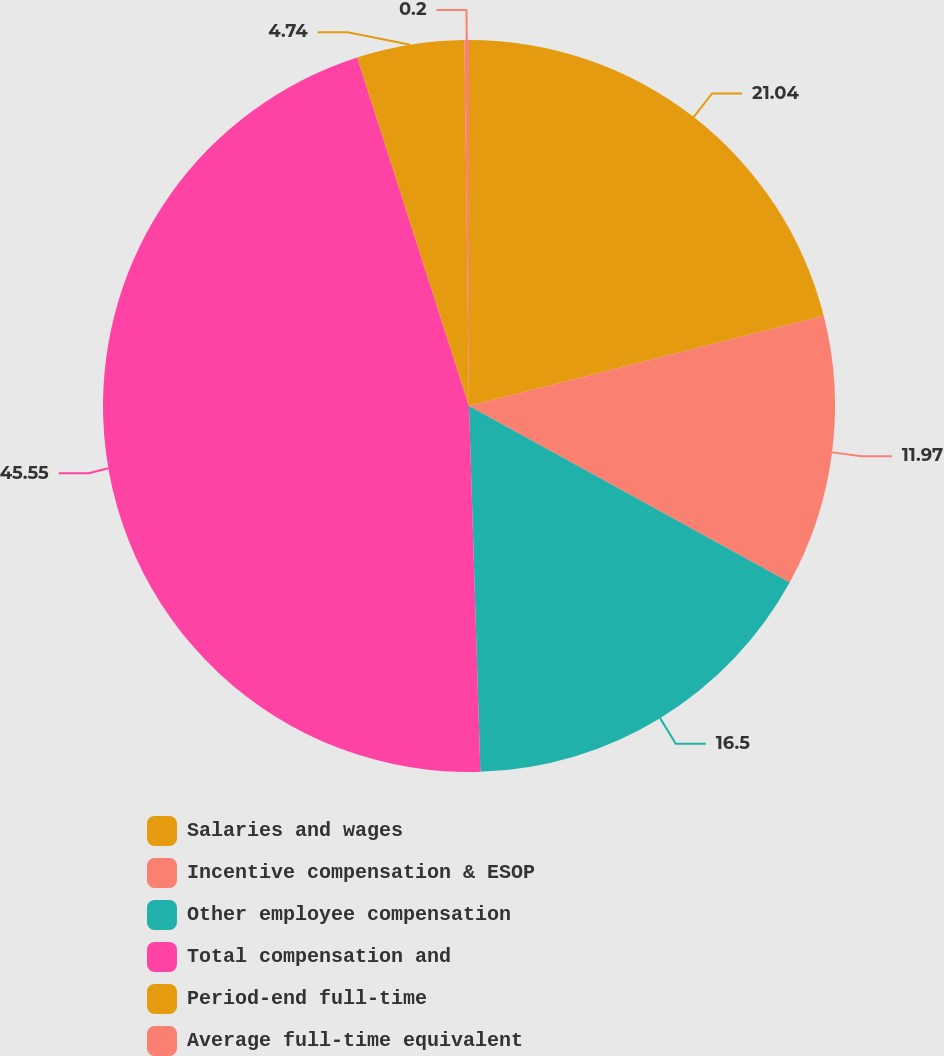Convert chart. <chart><loc_0><loc_0><loc_500><loc_500><pie_chart><fcel>Salaries and wages<fcel>Incentive compensation & ESOP<fcel>Other employee compensation<fcel>Total compensation and<fcel>Period-end full-time<fcel>Average full-time equivalent<nl><fcel>21.04%<fcel>11.97%<fcel>16.5%<fcel>45.56%<fcel>4.74%<fcel>0.2%<nl></chart> 